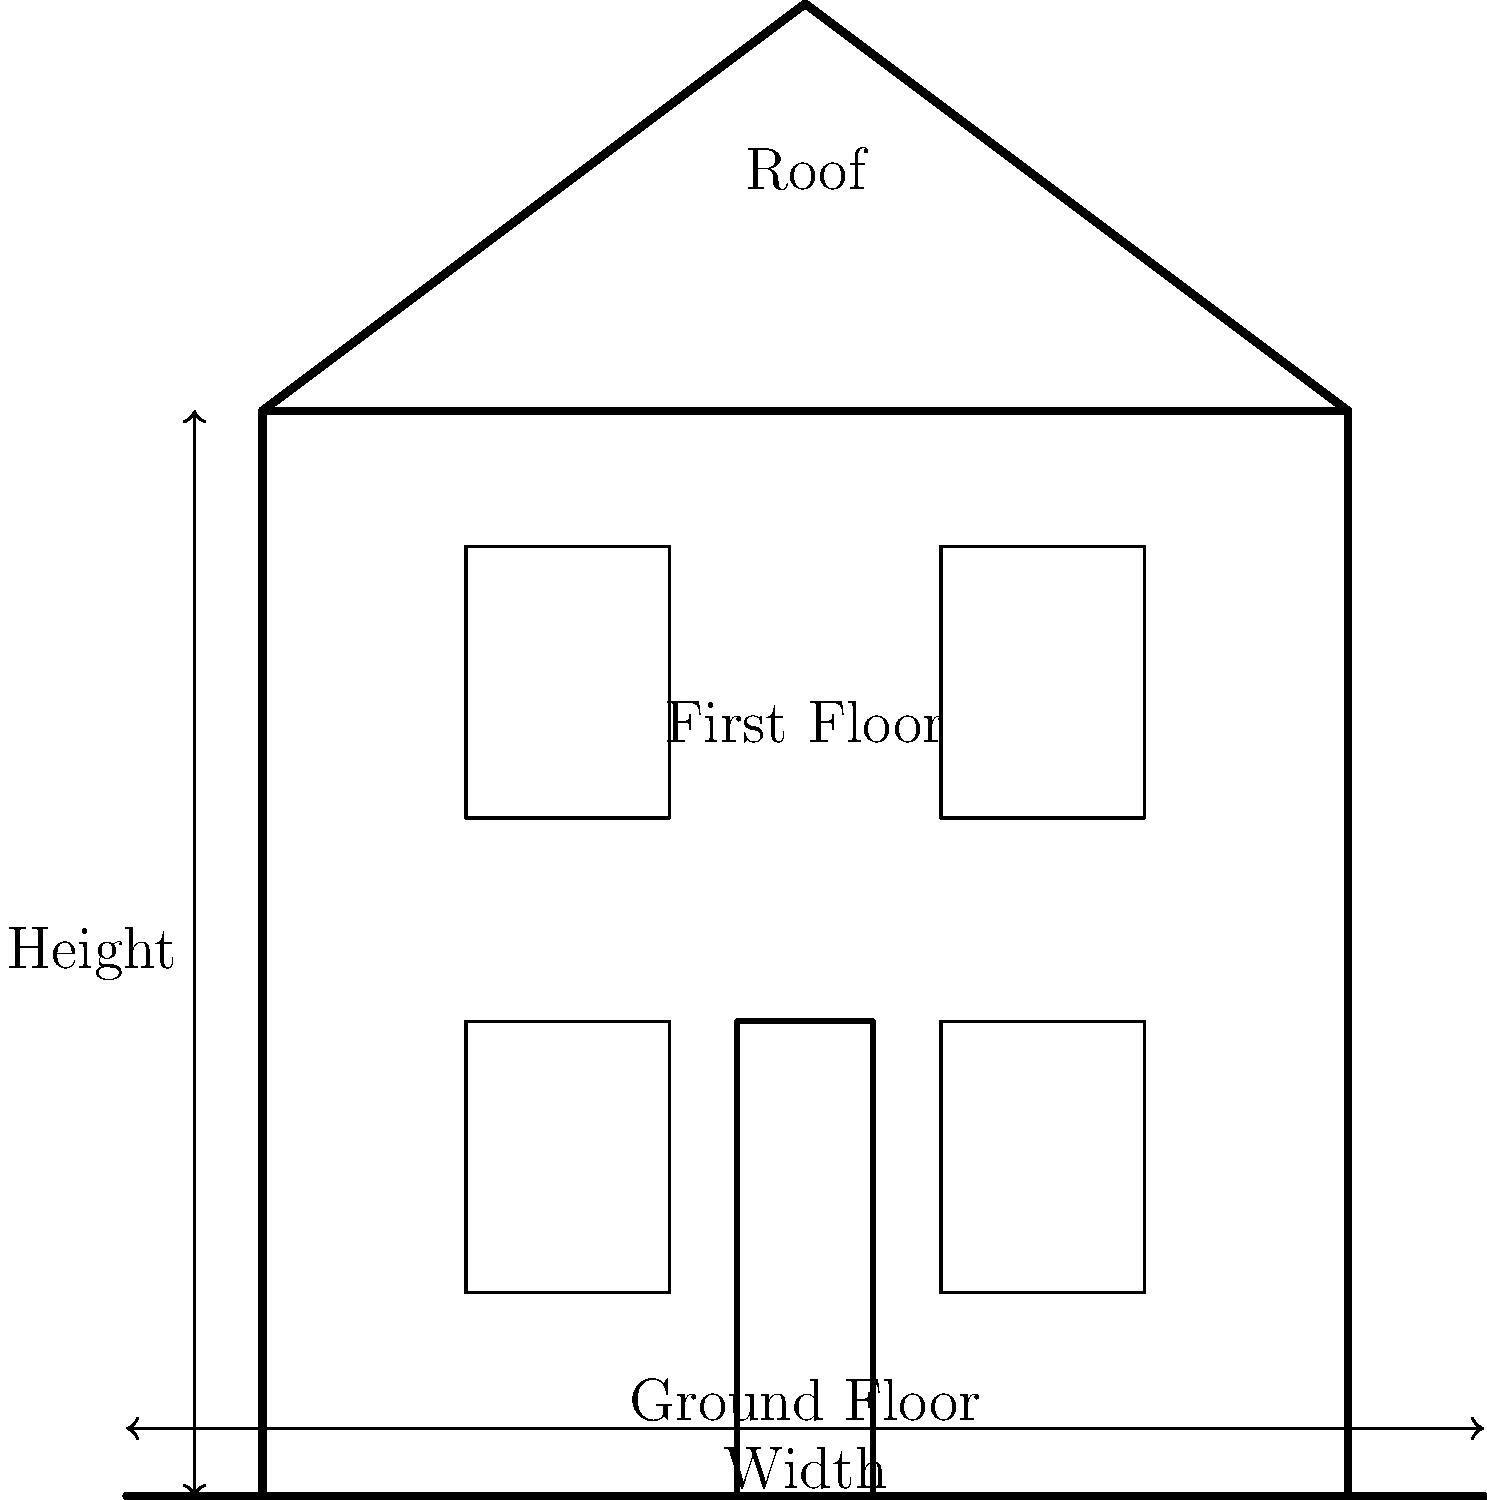In a typical Victorian terraced house, what is the approximate ratio of the house's height (from ground to roof peak) to its width, based on the architectural elevation shown? To determine the ratio of height to width in a typical Victorian terraced house, we need to analyze the architectural elevation provided:

1. Observe the structure:
   - The house has two floors (ground floor and first floor)
   - There's a pitched roof above the two floors

2. Estimate the proportions:
   - The ground floor and first floor appear to be of equal height
   - The roof adds approximately 3/8 of the total height of the two floors

3. Calculate the height:
   - Let's assume the width of the house is 1 unit
   - Each floor is approximately 4/8 of the width in height
   - Two floors together: 2 * (4/8) = 1 unit
   - Roof height: 3/8 of the width
   - Total height: 1 + 3/8 = 11/8 units

4. Express the ratio:
   - Height : Width = 11/8 : 1
   - This can be simplified to 1.375 : 1

5. Historical context:
   Victorian terraced houses were typically built with a focus on vertical space due to narrow plot sizes in urban areas. This resulted in houses that were often taller than they were wide, which is reflected in this ratio.
Answer: 1.375:1 